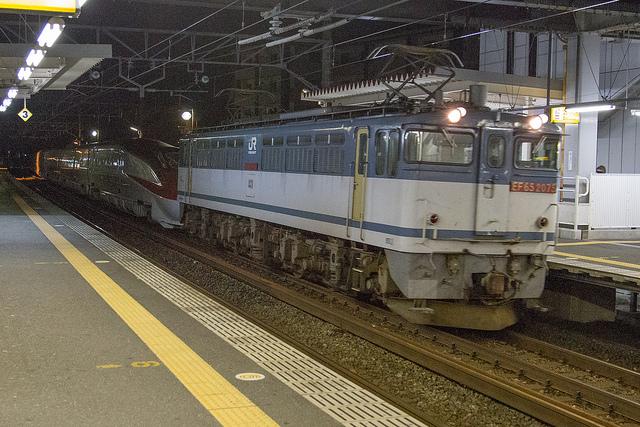Does this look like a comfortable place to lie down?
Give a very brief answer. No. Is this a subway?
Quick response, please. Yes. How many wheels do this picture have?
Be succinct. 20. 